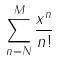<formula> <loc_0><loc_0><loc_500><loc_500>\sum _ { n = N } ^ { M } \frac { x ^ { n } } { n ! }</formula> 